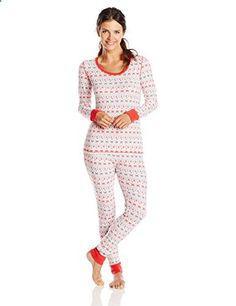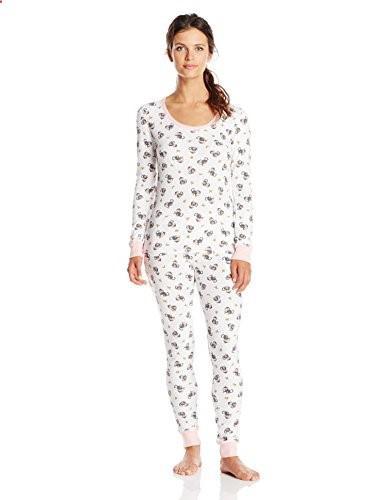The first image is the image on the left, the second image is the image on the right. Analyze the images presented: Is the assertion "Some of the pajamas are one piece and all of them have skin tight legs." valid? Answer yes or no. Yes. The first image is the image on the left, the second image is the image on the right. Examine the images to the left and right. Is the description "All of the girls are brunettes." accurate? Answer yes or no. Yes. The first image is the image on the left, the second image is the image on the right. Assess this claim about the two images: "One pair of pajamas has red trim around the neck and the ankles.". Correct or not? Answer yes or no. Yes. The first image is the image on the left, the second image is the image on the right. Examine the images to the left and right. Is the description "The girl on the left is wearing primarily gray pajamas." accurate? Answer yes or no. No. 